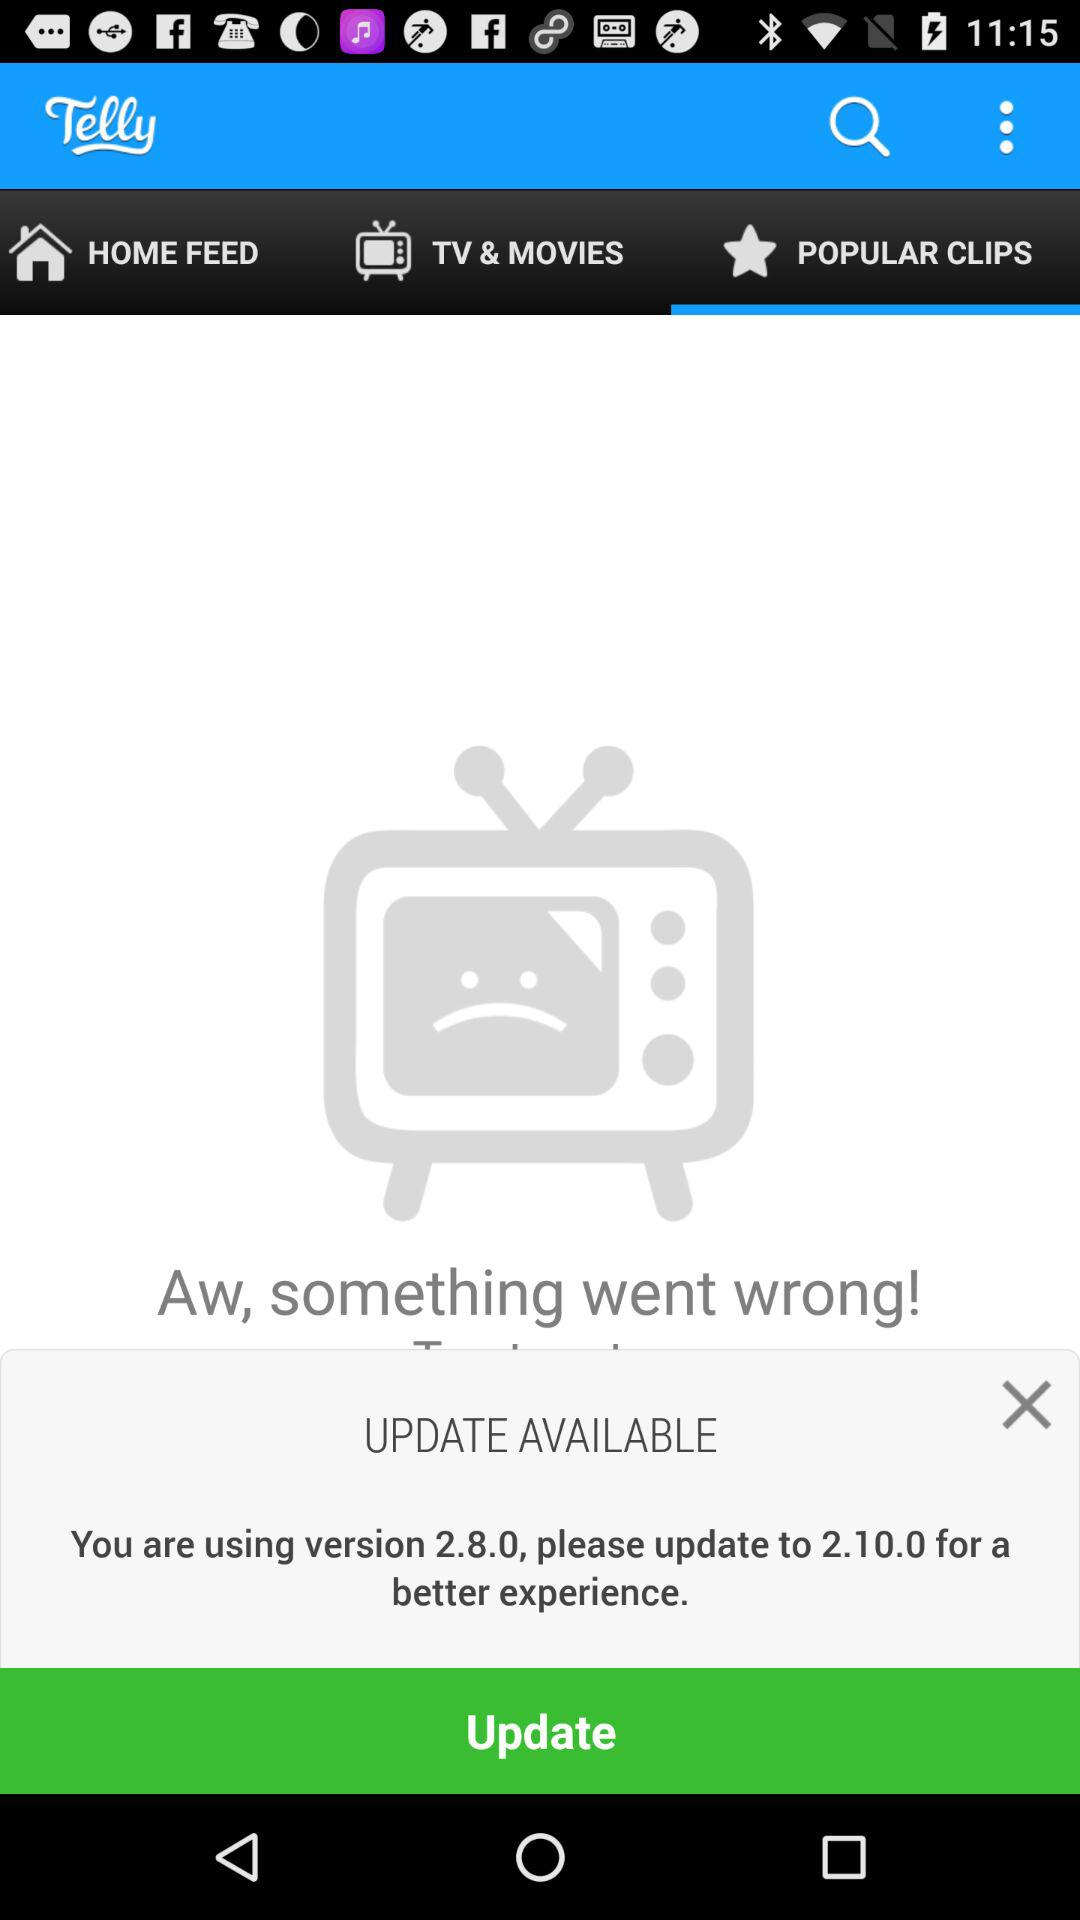Which is the new version? The new version is 2.10.0. 